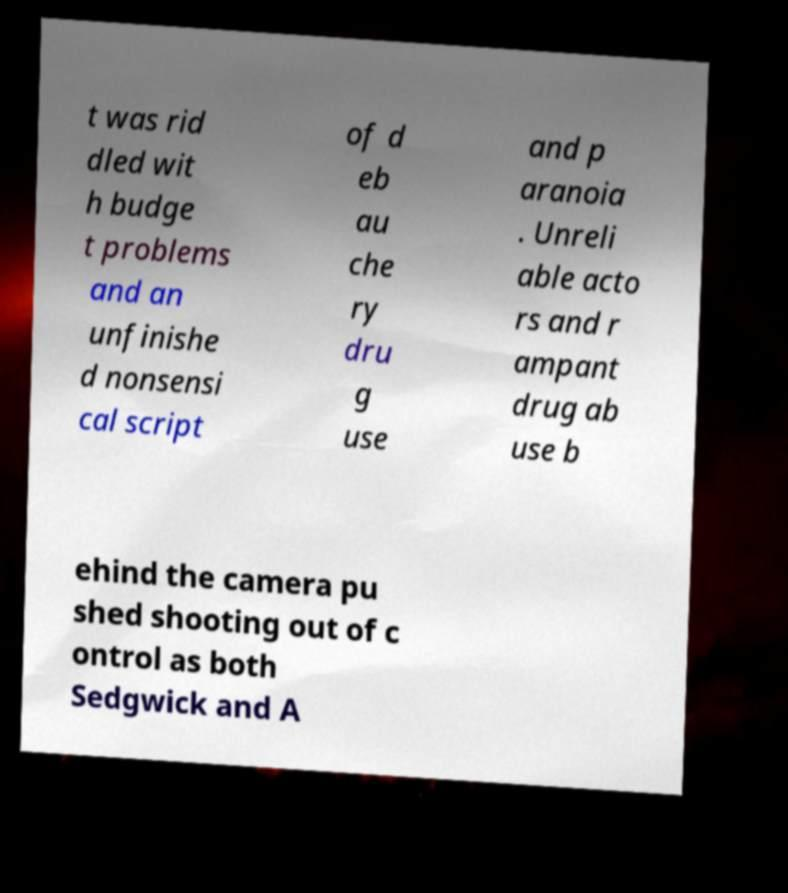Can you read and provide the text displayed in the image?This photo seems to have some interesting text. Can you extract and type it out for me? t was rid dled wit h budge t problems and an unfinishe d nonsensi cal script of d eb au che ry dru g use and p aranoia . Unreli able acto rs and r ampant drug ab use b ehind the camera pu shed shooting out of c ontrol as both Sedgwick and A 